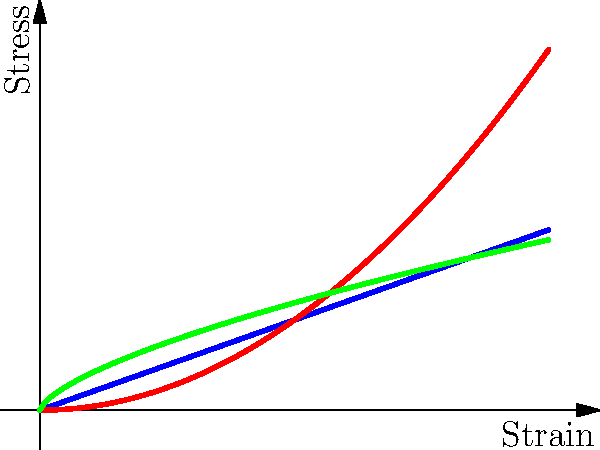As an investor who has learned the importance of thorough analysis, examine the stress-strain curves for materials A, B, and C. Which material exhibits the highest stiffness in the elastic region, and how does this relate to the concept of Young's modulus? To answer this question, let's analyze the stress-strain curves step-by-step:

1. Recall that Young's modulus (E) is defined as the ratio of stress (σ) to strain (ε) in the elastic region:

   $$ E = \frac{\sigma}{\varepsilon} $$

2. In the stress-strain curve, Young's modulus is represented by the slope of the linear portion (elastic region) of the curve.

3. Examining the curves:
   - Material A (blue): Shows a straight line, indicating a constant slope.
   - Material B (red): Shows a curve that starts with a high slope and decreases.
   - Material C (green): Shows a curve with an increasing slope.

4. The stiffness of a material is directly related to its Young's modulus. A higher Young's modulus indicates higher stiffness.

5. In the elastic region (initial part of the curve):
   - Material A has the steepest and constant slope.
   - Material B has a high initial slope that quickly decreases.
   - Material C has a lower initial slope that increases.

6. Therefore, Material A exhibits the highest and most consistent stiffness in the elastic region.

This analysis demonstrates the importance of understanding material properties in engineering applications, much like how thorough research is crucial in making sound investment decisions.
Answer: Material A exhibits the highest stiffness, with the steepest constant slope representing the highest Young's modulus. 